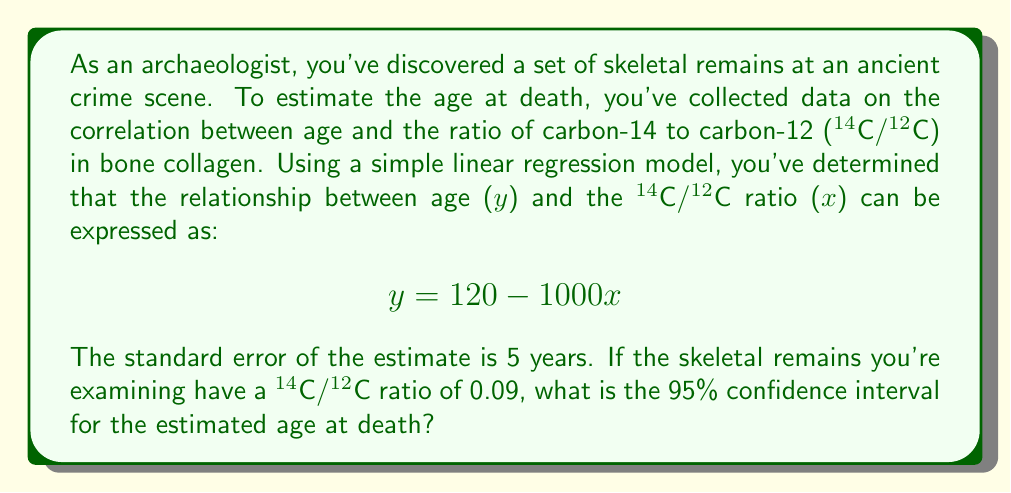Show me your answer to this math problem. To solve this problem, we'll follow these steps:

1) First, let's calculate the point estimate for the age using the given regression equation:
   $$y = 120 - 1000(0.09) = 120 - 90 = 30$$
   So, the point estimate for the age is 30 years.

2) For a 95% confidence interval, we need to find the margin of error. The formula is:
   $$\text{Margin of Error} = t_{critical} \times SE$$
   Where $t_{critical}$ is the t-value for a 95% confidence level with n-2 degrees of freedom, and SE is the standard error of the estimate.

3) We're given the SE (5 years), but we don't know the sample size. However, for large samples, the t-distribution approaches the normal distribution. So, we can use the z-score for 95% confidence, which is approximately 1.96.

4) Calculate the margin of error:
   $$\text{Margin of Error} = 1.96 \times 5 = 9.8$$

5) The confidence interval is then:
   $$\text{Point Estimate} \pm \text{Margin of Error}$$
   $$30 \pm 9.8$$

6) Therefore, the 95% confidence interval is:
   $$(30 - 9.8, 30 + 9.8) = (20.2, 39.8)$$

We can round this to whole years: (20, 40)
Answer: The 95% confidence interval for the estimated age at death is approximately 20 to 40 years. 